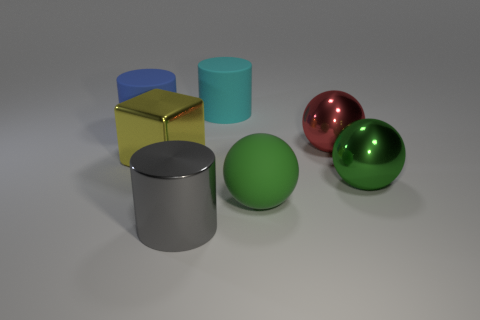How many metallic balls have the same color as the block?
Give a very brief answer. 0. How many cylinders are either red metallic things or large green things?
Provide a succinct answer. 0. There is a rubber sphere that is the same size as the blue cylinder; what color is it?
Offer a very short reply. Green. There is a cylinder in front of the big green thing that is left of the green metal object; is there a large cube right of it?
Give a very brief answer. No. The metal cube is what size?
Your answer should be very brief. Large. What number of objects are either brown metallic spheres or big gray metallic cylinders?
Provide a succinct answer. 1. The big cylinder that is made of the same material as the yellow object is what color?
Your answer should be compact. Gray. There is a shiny object to the left of the gray cylinder; does it have the same shape as the large cyan thing?
Your answer should be compact. No. What number of objects are things behind the shiny cylinder or metallic objects behind the metal block?
Offer a terse response. 6. There is a large metallic thing that is the same shape as the blue matte object; what color is it?
Ensure brevity in your answer.  Gray. 